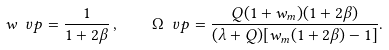Convert formula to latex. <formula><loc_0><loc_0><loc_500><loc_500>w _ { \ } v p = \frac { 1 } { 1 + 2 \beta } \, , \quad \Omega _ { \ } v p = \frac { Q ( 1 + w _ { m } ) ( 1 + 2 \beta ) } { ( \lambda + Q ) [ w _ { m } ( 1 + 2 \beta ) - 1 ] } .</formula> 